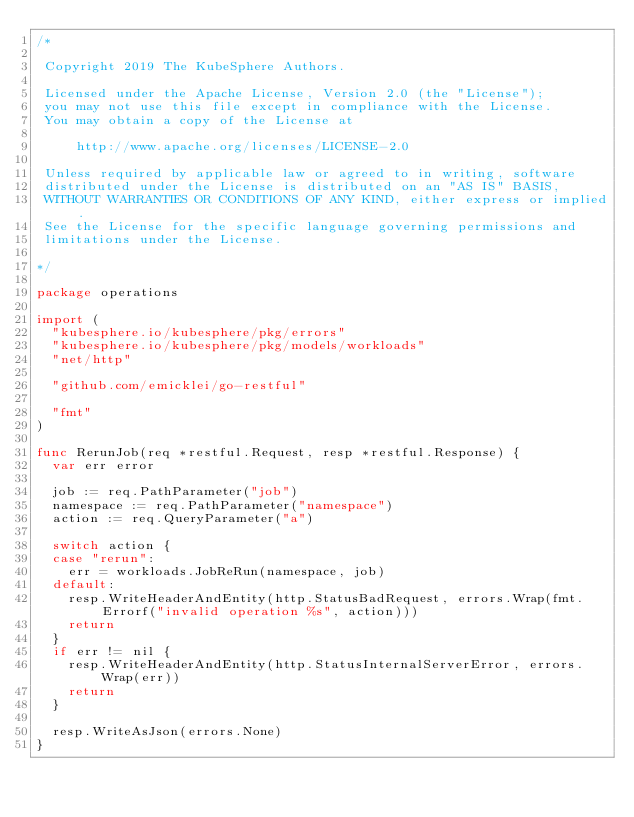Convert code to text. <code><loc_0><loc_0><loc_500><loc_500><_Go_>/*

 Copyright 2019 The KubeSphere Authors.

 Licensed under the Apache License, Version 2.0 (the "License");
 you may not use this file except in compliance with the License.
 You may obtain a copy of the License at

     http://www.apache.org/licenses/LICENSE-2.0

 Unless required by applicable law or agreed to in writing, software
 distributed under the License is distributed on an "AS IS" BASIS,
 WITHOUT WARRANTIES OR CONDITIONS OF ANY KIND, either express or implied.
 See the License for the specific language governing permissions and
 limitations under the License.

*/

package operations

import (
	"kubesphere.io/kubesphere/pkg/errors"
	"kubesphere.io/kubesphere/pkg/models/workloads"
	"net/http"

	"github.com/emicklei/go-restful"

	"fmt"
)

func RerunJob(req *restful.Request, resp *restful.Response) {
	var err error

	job := req.PathParameter("job")
	namespace := req.PathParameter("namespace")
	action := req.QueryParameter("a")

	switch action {
	case "rerun":
		err = workloads.JobReRun(namespace, job)
	default:
		resp.WriteHeaderAndEntity(http.StatusBadRequest, errors.Wrap(fmt.Errorf("invalid operation %s", action)))
		return
	}
	if err != nil {
		resp.WriteHeaderAndEntity(http.StatusInternalServerError, errors.Wrap(err))
		return
	}

	resp.WriteAsJson(errors.None)
}
</code> 